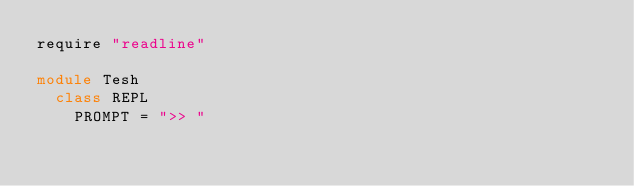<code> <loc_0><loc_0><loc_500><loc_500><_Crystal_>require "readline"

module Tesh
  class REPL
    PROMPT = ">> "
</code> 